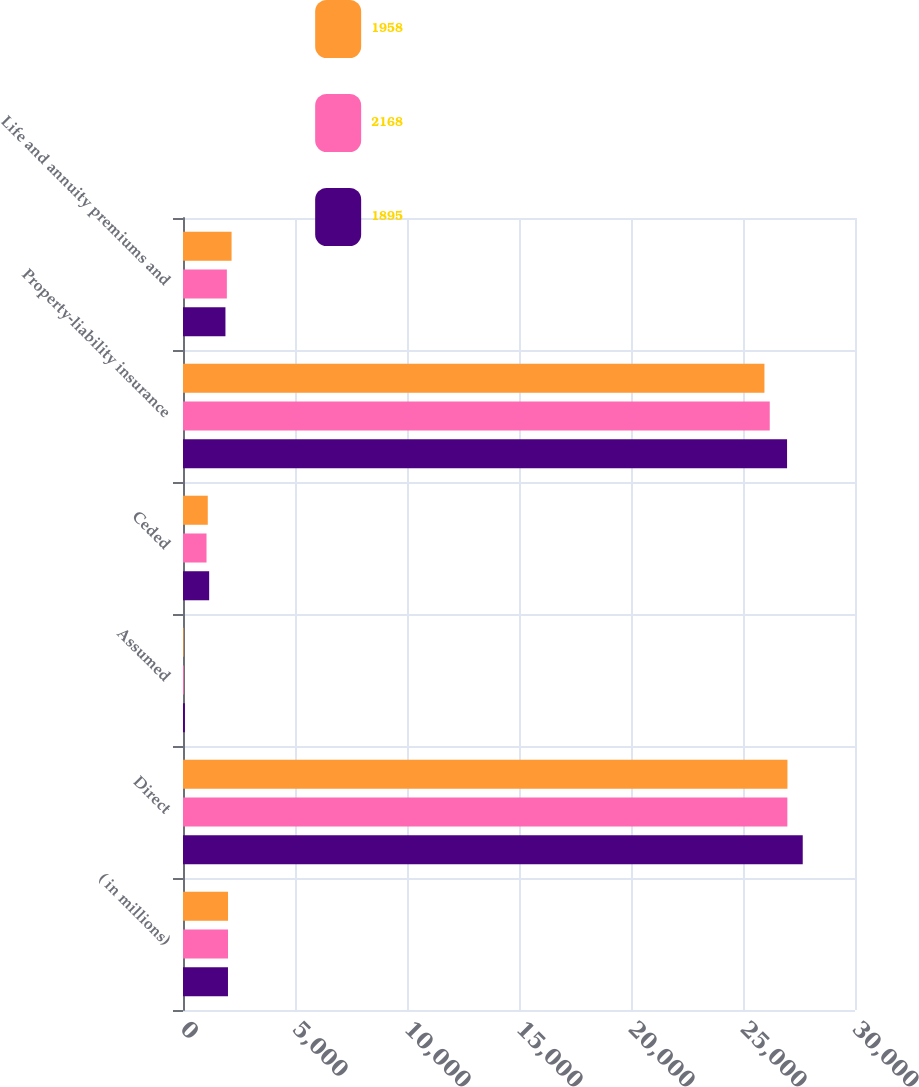<chart> <loc_0><loc_0><loc_500><loc_500><stacked_bar_chart><ecel><fcel>( in millions)<fcel>Direct<fcel>Assumed<fcel>Ceded<fcel>Property-liability insurance<fcel>Life and annuity premiums and<nl><fcel>1958<fcel>2010<fcel>26984<fcel>29<fcel>1106<fcel>25957<fcel>2168<nl><fcel>2168<fcel>2009<fcel>26980<fcel>41<fcel>1050<fcel>26194<fcel>1958<nl><fcel>1895<fcel>2008<fcel>27667<fcel>85<fcel>1168<fcel>26967<fcel>1895<nl></chart> 